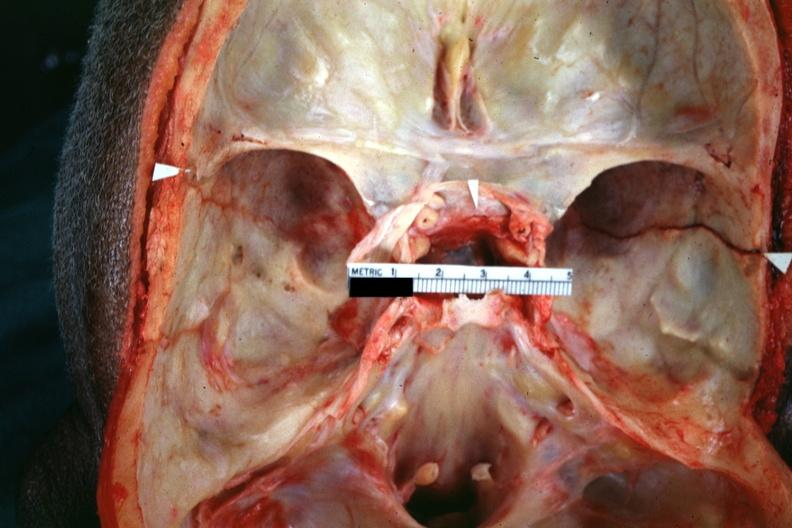s bone, calvarium present?
Answer the question using a single word or phrase. Yes 